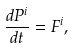<formula> <loc_0><loc_0><loc_500><loc_500>\frac { d P ^ { i } } { d t } = F ^ { i } ,</formula> 